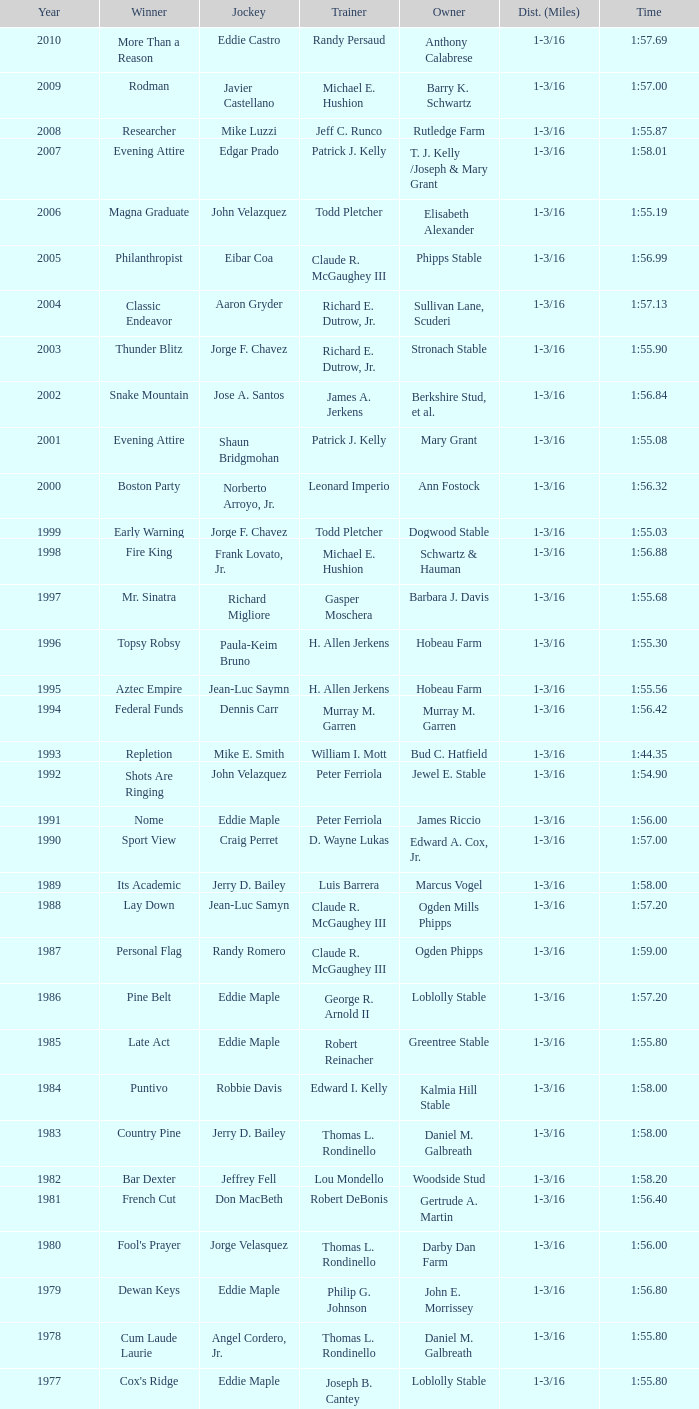What horse won with a trainer of "no race"? No Race, No Race, No Race, No Race. 